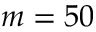<formula> <loc_0><loc_0><loc_500><loc_500>m = 5 0</formula> 